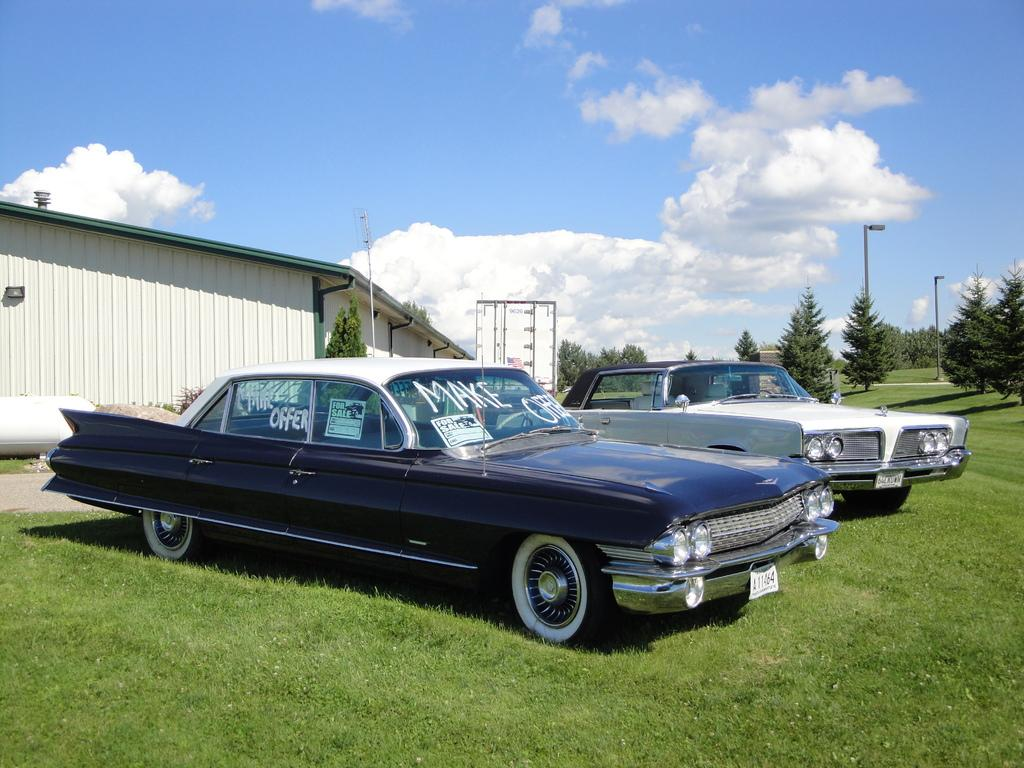What is on the grass in the image? There are vehicles on the grass in the image. What can be seen in the background of the image? There are trees, light poles, a house, and clouds visible in the sky in the background of the image. What type of scarf is being used to skate on the grass in the image? There is no scarf or skating activity present in the image; it features vehicles on the grass. What request is being made by the house in the background of the image? There is no request being made by the house in the image; it is a stationary structure in the background. 